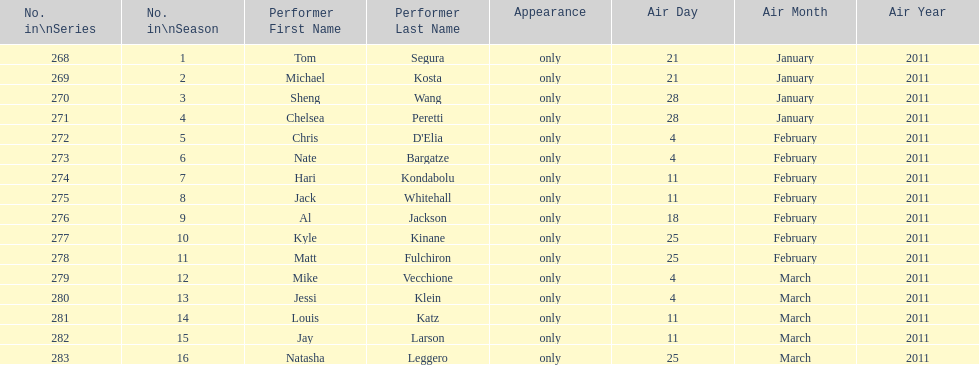Did al jackson air before or after kyle kinane? Before. 